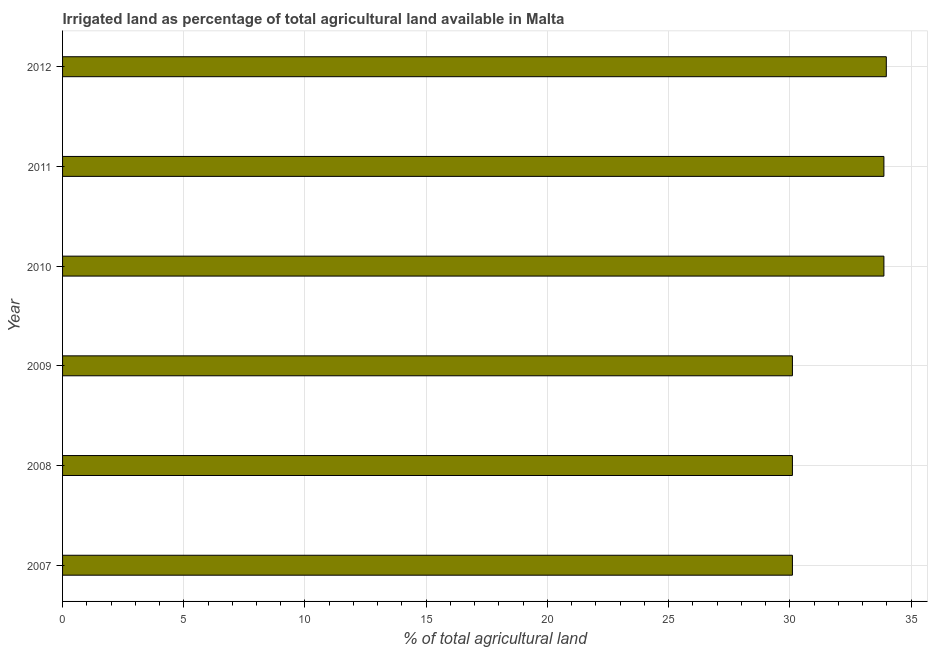Does the graph contain grids?
Ensure brevity in your answer.  Yes. What is the title of the graph?
Your answer should be very brief. Irrigated land as percentage of total agricultural land available in Malta. What is the label or title of the X-axis?
Give a very brief answer. % of total agricultural land. What is the percentage of agricultural irrigated land in 2012?
Keep it short and to the point. 33.98. Across all years, what is the maximum percentage of agricultural irrigated land?
Give a very brief answer. 33.98. Across all years, what is the minimum percentage of agricultural irrigated land?
Provide a succinct answer. 30.11. In which year was the percentage of agricultural irrigated land minimum?
Make the answer very short. 2007. What is the sum of the percentage of agricultural irrigated land?
Provide a succinct answer. 192.07. What is the average percentage of agricultural irrigated land per year?
Give a very brief answer. 32.01. What is the median percentage of agricultural irrigated land?
Provide a succinct answer. 31.99. Do a majority of the years between 2008 and 2010 (inclusive) have percentage of agricultural irrigated land greater than 24 %?
Give a very brief answer. Yes. Is the percentage of agricultural irrigated land in 2009 less than that in 2011?
Keep it short and to the point. Yes. Is the difference between the percentage of agricultural irrigated land in 2008 and 2009 greater than the difference between any two years?
Your response must be concise. No. What is the difference between the highest and the second highest percentage of agricultural irrigated land?
Ensure brevity in your answer.  0.1. Is the sum of the percentage of agricultural irrigated land in 2008 and 2010 greater than the maximum percentage of agricultural irrigated land across all years?
Your answer should be compact. Yes. What is the difference between the highest and the lowest percentage of agricultural irrigated land?
Keep it short and to the point. 3.87. How many bars are there?
Offer a terse response. 6. Are the values on the major ticks of X-axis written in scientific E-notation?
Provide a succinct answer. No. What is the % of total agricultural land of 2007?
Provide a succinct answer. 30.11. What is the % of total agricultural land of 2008?
Provide a succinct answer. 30.11. What is the % of total agricultural land of 2009?
Make the answer very short. 30.11. What is the % of total agricultural land in 2010?
Offer a very short reply. 33.88. What is the % of total agricultural land in 2011?
Provide a succinct answer. 33.88. What is the % of total agricultural land of 2012?
Give a very brief answer. 33.98. What is the difference between the % of total agricultural land in 2007 and 2009?
Provide a short and direct response. 0. What is the difference between the % of total agricultural land in 2007 and 2010?
Give a very brief answer. -3.77. What is the difference between the % of total agricultural land in 2007 and 2011?
Your answer should be compact. -3.77. What is the difference between the % of total agricultural land in 2007 and 2012?
Make the answer very short. -3.87. What is the difference between the % of total agricultural land in 2008 and 2010?
Your answer should be compact. -3.77. What is the difference between the % of total agricultural land in 2008 and 2011?
Give a very brief answer. -3.77. What is the difference between the % of total agricultural land in 2008 and 2012?
Your answer should be very brief. -3.87. What is the difference between the % of total agricultural land in 2009 and 2010?
Your response must be concise. -3.77. What is the difference between the % of total agricultural land in 2009 and 2011?
Make the answer very short. -3.77. What is the difference between the % of total agricultural land in 2009 and 2012?
Offer a terse response. -3.87. What is the difference between the % of total agricultural land in 2010 and 2011?
Provide a succinct answer. 0. What is the difference between the % of total agricultural land in 2010 and 2012?
Your answer should be very brief. -0.1. What is the difference between the % of total agricultural land in 2011 and 2012?
Make the answer very short. -0.1. What is the ratio of the % of total agricultural land in 2007 to that in 2008?
Offer a very short reply. 1. What is the ratio of the % of total agricultural land in 2007 to that in 2009?
Provide a succinct answer. 1. What is the ratio of the % of total agricultural land in 2007 to that in 2010?
Give a very brief answer. 0.89. What is the ratio of the % of total agricultural land in 2007 to that in 2011?
Offer a terse response. 0.89. What is the ratio of the % of total agricultural land in 2007 to that in 2012?
Offer a very short reply. 0.89. What is the ratio of the % of total agricultural land in 2008 to that in 2010?
Keep it short and to the point. 0.89. What is the ratio of the % of total agricultural land in 2008 to that in 2011?
Provide a short and direct response. 0.89. What is the ratio of the % of total agricultural land in 2008 to that in 2012?
Your answer should be very brief. 0.89. What is the ratio of the % of total agricultural land in 2009 to that in 2010?
Give a very brief answer. 0.89. What is the ratio of the % of total agricultural land in 2009 to that in 2011?
Offer a terse response. 0.89. What is the ratio of the % of total agricultural land in 2009 to that in 2012?
Your answer should be compact. 0.89. What is the ratio of the % of total agricultural land in 2011 to that in 2012?
Give a very brief answer. 1. 